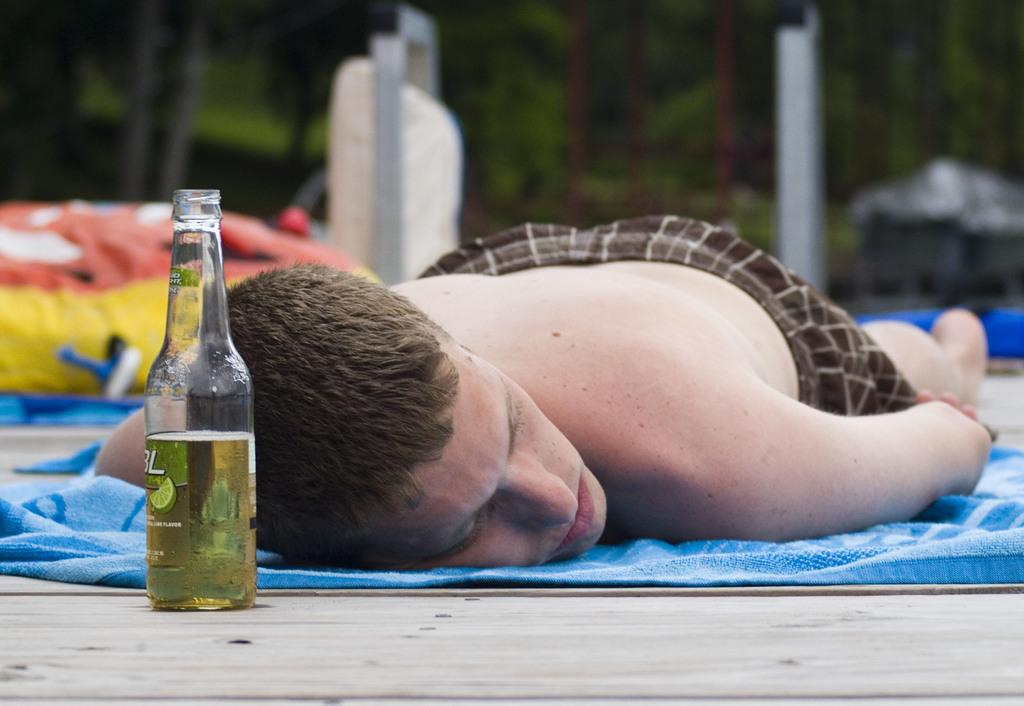What is the person in the image doing? The person is lying down in the image. What object is in front of the person? There is a bottle in front of the person. What can be seen in the background of the image? There are trees behind the person. What type of cork is used to seal the bottle in the image? There is no information about the type of cork used to seal the bottle in the image, nor is there any visible cork. 